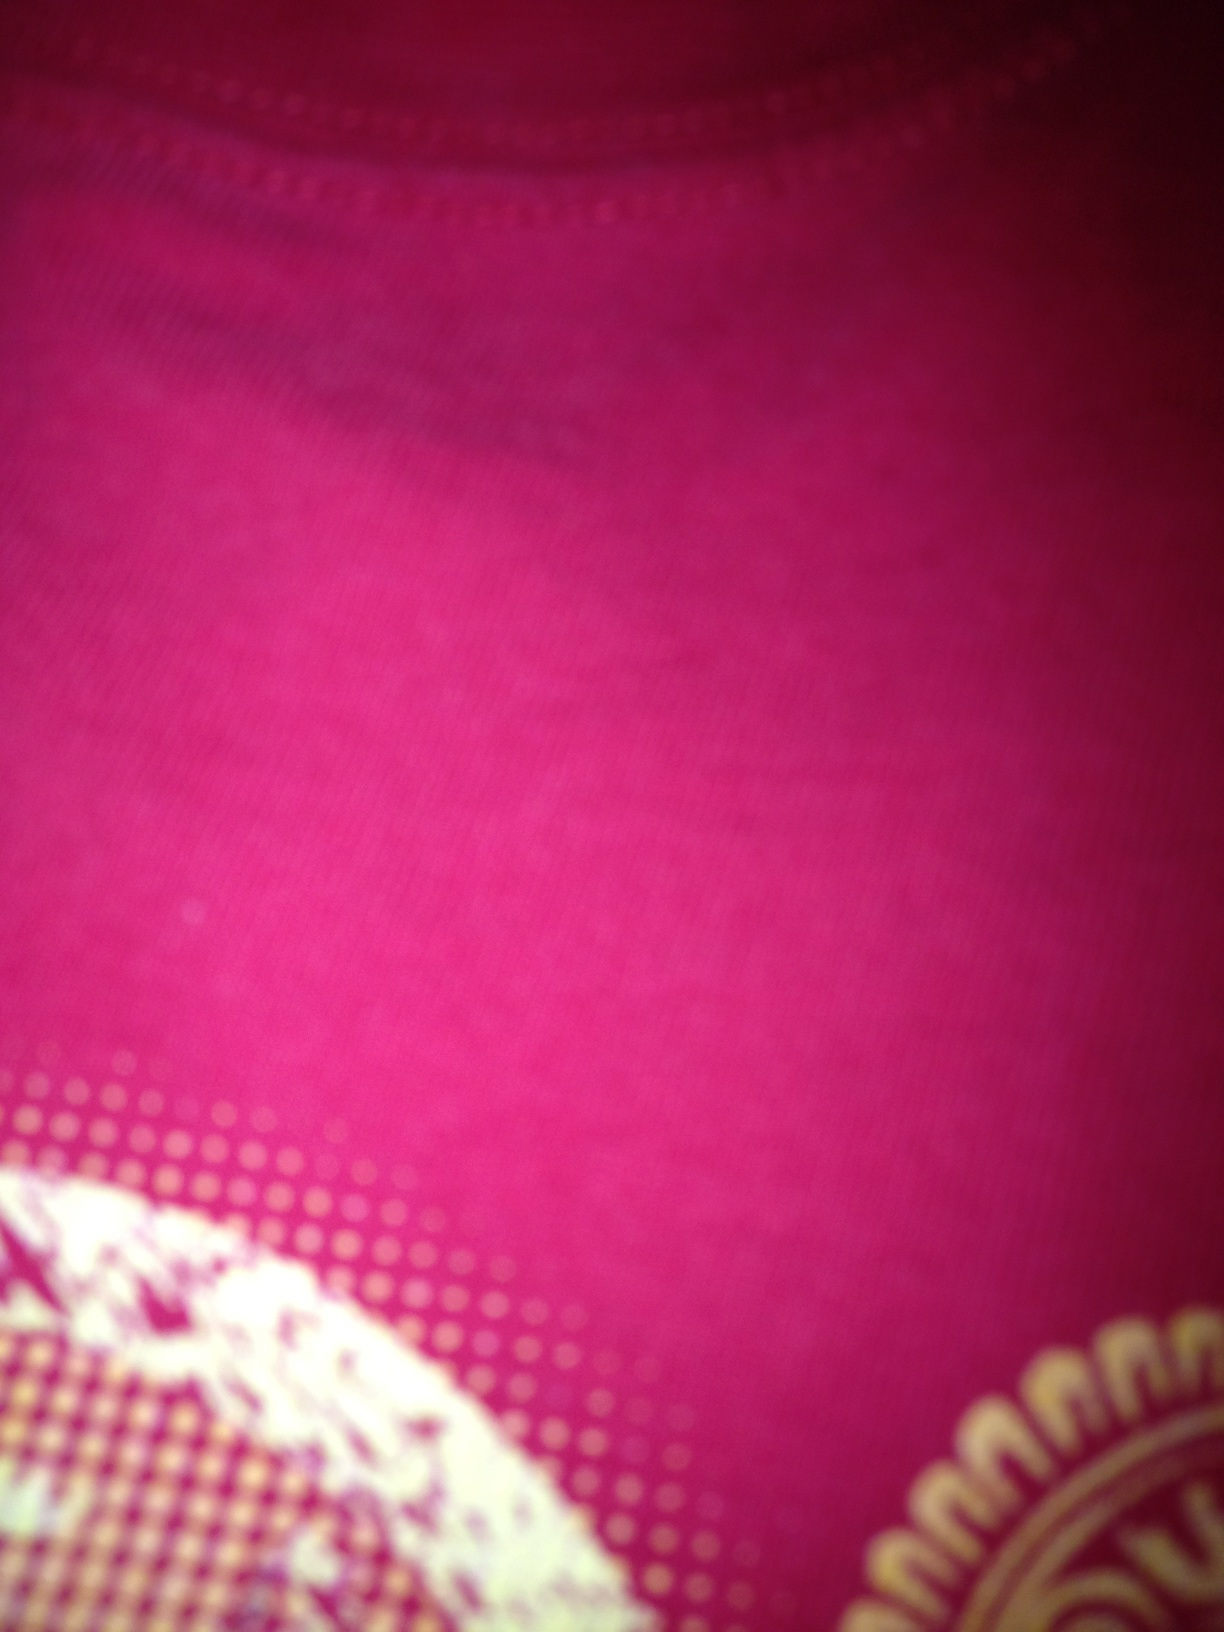This looks like a close-up. Can you guess what the item might be used for? Given the texture and pattern visible in the image, it's likely that this is a close-up of a garment, possibly a scarf, shirt, or traditional dress, which would be used for wearing as a part of personal attire. 